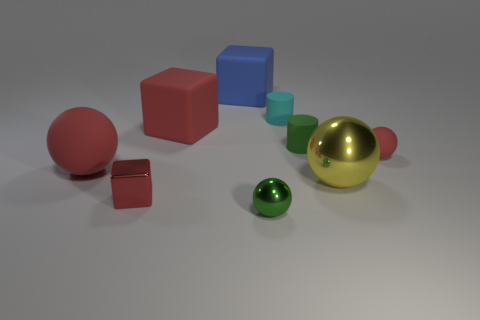There is a large sphere that is in front of the red rubber sphere that is to the left of the small green metallic thing; what number of blue things are right of it?
Your response must be concise. 0. How many red rubber objects have the same shape as the yellow metallic thing?
Your response must be concise. 2. Does the small ball to the left of the tiny red sphere have the same color as the big metallic object?
Your answer should be very brief. No. The big rubber thing that is behind the big red rubber object that is behind the small red object behind the small cube is what shape?
Make the answer very short. Cube. There is a blue block; does it have the same size as the red matte thing that is to the left of the red rubber block?
Your answer should be very brief. Yes. Is there a cyan rubber thing that has the same size as the cyan matte cylinder?
Your response must be concise. No. What number of other things are there of the same material as the tiny green sphere
Offer a very short reply. 2. What is the color of the small object that is right of the small cyan thing and left of the yellow metal ball?
Ensure brevity in your answer.  Green. Is the green thing that is in front of the green rubber cylinder made of the same material as the red ball that is to the right of the cyan matte cylinder?
Ensure brevity in your answer.  No. There is a cylinder behind the green rubber thing; does it have the same size as the red metal thing?
Make the answer very short. Yes. 